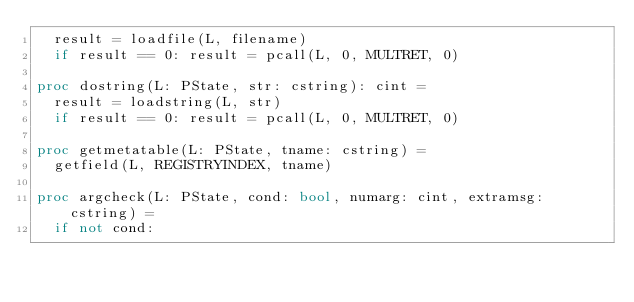Convert code to text. <code><loc_0><loc_0><loc_500><loc_500><_Nim_>  result = loadfile(L, filename)
  if result == 0: result = pcall(L, 0, MULTRET, 0)
  
proc dostring(L: PState, str: cstring): cint = 
  result = loadstring(L, str)
  if result == 0: result = pcall(L, 0, MULTRET, 0)
  
proc getmetatable(L: PState, tname: cstring) = 
  getfield(L, REGISTRYINDEX, tname)

proc argcheck(L: PState, cond: bool, numarg: cint, extramsg: cstring) = 
  if not cond: </code> 